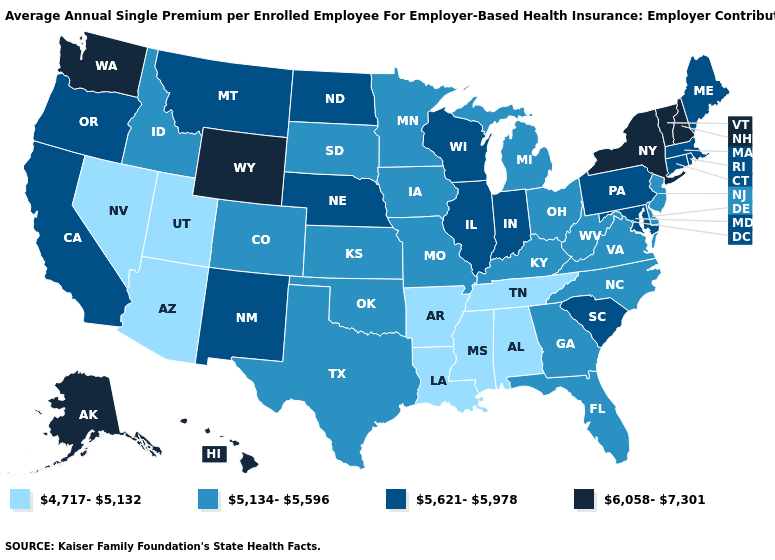What is the value of New Hampshire?
Quick response, please. 6,058-7,301. Which states have the highest value in the USA?
Answer briefly. Alaska, Hawaii, New Hampshire, New York, Vermont, Washington, Wyoming. What is the value of Idaho?
Answer briefly. 5,134-5,596. Does New York have the highest value in the USA?
Be succinct. Yes. Which states have the lowest value in the USA?
Be succinct. Alabama, Arizona, Arkansas, Louisiana, Mississippi, Nevada, Tennessee, Utah. What is the highest value in the MidWest ?
Be succinct. 5,621-5,978. Among the states that border Illinois , does Kentucky have the highest value?
Be succinct. No. Does Maine have the highest value in the Northeast?
Short answer required. No. Does North Carolina have a higher value than Texas?
Give a very brief answer. No. Name the states that have a value in the range 5,134-5,596?
Concise answer only. Colorado, Delaware, Florida, Georgia, Idaho, Iowa, Kansas, Kentucky, Michigan, Minnesota, Missouri, New Jersey, North Carolina, Ohio, Oklahoma, South Dakota, Texas, Virginia, West Virginia. Name the states that have a value in the range 5,134-5,596?
Be succinct. Colorado, Delaware, Florida, Georgia, Idaho, Iowa, Kansas, Kentucky, Michigan, Minnesota, Missouri, New Jersey, North Carolina, Ohio, Oklahoma, South Dakota, Texas, Virginia, West Virginia. What is the lowest value in the USA?
Be succinct. 4,717-5,132. Does Virginia have a lower value than Indiana?
Answer briefly. Yes. Among the states that border South Dakota , does Wyoming have the highest value?
Concise answer only. Yes. Does New Jersey have the lowest value in the Northeast?
Give a very brief answer. Yes. 